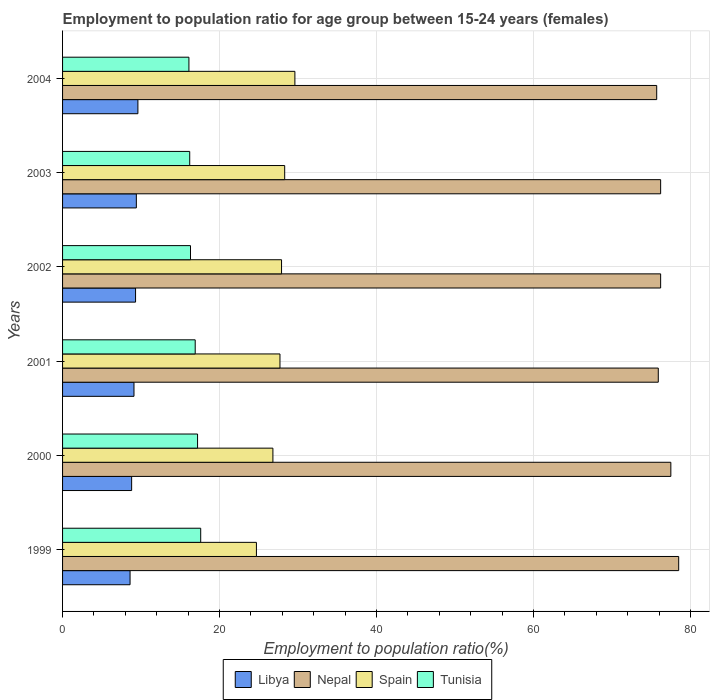How many bars are there on the 5th tick from the top?
Your answer should be compact. 4. How many bars are there on the 6th tick from the bottom?
Keep it short and to the point. 4. What is the label of the 3rd group of bars from the top?
Make the answer very short. 2002. What is the employment to population ratio in Libya in 1999?
Keep it short and to the point. 8.6. Across all years, what is the maximum employment to population ratio in Spain?
Offer a very short reply. 29.6. Across all years, what is the minimum employment to population ratio in Tunisia?
Ensure brevity in your answer.  16.1. In which year was the employment to population ratio in Nepal minimum?
Provide a succinct answer. 2004. What is the total employment to population ratio in Libya in the graph?
Offer a very short reply. 54.8. What is the difference between the employment to population ratio in Libya in 2004 and the employment to population ratio in Tunisia in 2001?
Make the answer very short. -7.3. What is the average employment to population ratio in Nepal per year?
Provide a succinct answer. 76.67. In the year 2004, what is the difference between the employment to population ratio in Spain and employment to population ratio in Nepal?
Give a very brief answer. -46.1. In how many years, is the employment to population ratio in Nepal greater than 32 %?
Give a very brief answer. 6. What is the ratio of the employment to population ratio in Spain in 2001 to that in 2003?
Your response must be concise. 0.98. Is the difference between the employment to population ratio in Spain in 2000 and 2004 greater than the difference between the employment to population ratio in Nepal in 2000 and 2004?
Make the answer very short. No. What is the difference between the highest and the second highest employment to population ratio in Libya?
Your answer should be compact. 0.2. What is the difference between the highest and the lowest employment to population ratio in Nepal?
Your answer should be very brief. 2.8. Is the sum of the employment to population ratio in Libya in 2002 and 2003 greater than the maximum employment to population ratio in Spain across all years?
Your response must be concise. No. What does the 2nd bar from the top in 2000 represents?
Provide a succinct answer. Spain. What does the 3rd bar from the bottom in 2004 represents?
Offer a terse response. Spain. Is it the case that in every year, the sum of the employment to population ratio in Tunisia and employment to population ratio in Libya is greater than the employment to population ratio in Spain?
Offer a very short reply. No. How many bars are there?
Your answer should be very brief. 24. How many years are there in the graph?
Provide a short and direct response. 6. Does the graph contain any zero values?
Make the answer very short. No. Does the graph contain grids?
Ensure brevity in your answer.  Yes. Where does the legend appear in the graph?
Offer a terse response. Bottom center. How are the legend labels stacked?
Offer a very short reply. Horizontal. What is the title of the graph?
Provide a short and direct response. Employment to population ratio for age group between 15-24 years (females). What is the label or title of the Y-axis?
Your answer should be compact. Years. What is the Employment to population ratio(%) in Libya in 1999?
Ensure brevity in your answer.  8.6. What is the Employment to population ratio(%) in Nepal in 1999?
Provide a short and direct response. 78.5. What is the Employment to population ratio(%) in Spain in 1999?
Make the answer very short. 24.7. What is the Employment to population ratio(%) of Tunisia in 1999?
Your response must be concise. 17.6. What is the Employment to population ratio(%) of Libya in 2000?
Your answer should be compact. 8.8. What is the Employment to population ratio(%) of Nepal in 2000?
Provide a succinct answer. 77.5. What is the Employment to population ratio(%) in Spain in 2000?
Provide a short and direct response. 26.8. What is the Employment to population ratio(%) in Tunisia in 2000?
Offer a very short reply. 17.2. What is the Employment to population ratio(%) of Libya in 2001?
Your answer should be very brief. 9.1. What is the Employment to population ratio(%) in Nepal in 2001?
Keep it short and to the point. 75.9. What is the Employment to population ratio(%) in Spain in 2001?
Keep it short and to the point. 27.7. What is the Employment to population ratio(%) in Tunisia in 2001?
Provide a short and direct response. 16.9. What is the Employment to population ratio(%) in Libya in 2002?
Provide a short and direct response. 9.3. What is the Employment to population ratio(%) in Nepal in 2002?
Your response must be concise. 76.2. What is the Employment to population ratio(%) of Spain in 2002?
Offer a very short reply. 27.9. What is the Employment to population ratio(%) of Tunisia in 2002?
Provide a succinct answer. 16.3. What is the Employment to population ratio(%) in Libya in 2003?
Make the answer very short. 9.4. What is the Employment to population ratio(%) of Nepal in 2003?
Your response must be concise. 76.2. What is the Employment to population ratio(%) in Spain in 2003?
Your answer should be very brief. 28.3. What is the Employment to population ratio(%) of Tunisia in 2003?
Ensure brevity in your answer.  16.2. What is the Employment to population ratio(%) of Libya in 2004?
Provide a short and direct response. 9.6. What is the Employment to population ratio(%) of Nepal in 2004?
Provide a short and direct response. 75.7. What is the Employment to population ratio(%) in Spain in 2004?
Keep it short and to the point. 29.6. What is the Employment to population ratio(%) in Tunisia in 2004?
Make the answer very short. 16.1. Across all years, what is the maximum Employment to population ratio(%) of Libya?
Your answer should be very brief. 9.6. Across all years, what is the maximum Employment to population ratio(%) of Nepal?
Your answer should be very brief. 78.5. Across all years, what is the maximum Employment to population ratio(%) of Spain?
Your response must be concise. 29.6. Across all years, what is the maximum Employment to population ratio(%) in Tunisia?
Provide a succinct answer. 17.6. Across all years, what is the minimum Employment to population ratio(%) in Libya?
Your response must be concise. 8.6. Across all years, what is the minimum Employment to population ratio(%) of Nepal?
Your answer should be very brief. 75.7. Across all years, what is the minimum Employment to population ratio(%) in Spain?
Your response must be concise. 24.7. Across all years, what is the minimum Employment to population ratio(%) in Tunisia?
Your response must be concise. 16.1. What is the total Employment to population ratio(%) in Libya in the graph?
Your response must be concise. 54.8. What is the total Employment to population ratio(%) of Nepal in the graph?
Make the answer very short. 460. What is the total Employment to population ratio(%) in Spain in the graph?
Give a very brief answer. 165. What is the total Employment to population ratio(%) in Tunisia in the graph?
Give a very brief answer. 100.3. What is the difference between the Employment to population ratio(%) of Libya in 1999 and that in 2000?
Make the answer very short. -0.2. What is the difference between the Employment to population ratio(%) of Tunisia in 1999 and that in 2000?
Provide a short and direct response. 0.4. What is the difference between the Employment to population ratio(%) of Spain in 1999 and that in 2001?
Your answer should be compact. -3. What is the difference between the Employment to population ratio(%) of Tunisia in 1999 and that in 2002?
Your answer should be very brief. 1.3. What is the difference between the Employment to population ratio(%) of Spain in 1999 and that in 2003?
Your answer should be compact. -3.6. What is the difference between the Employment to population ratio(%) of Tunisia in 1999 and that in 2003?
Offer a very short reply. 1.4. What is the difference between the Employment to population ratio(%) in Libya in 1999 and that in 2004?
Your answer should be very brief. -1. What is the difference between the Employment to population ratio(%) of Libya in 2000 and that in 2001?
Keep it short and to the point. -0.3. What is the difference between the Employment to population ratio(%) of Nepal in 2000 and that in 2001?
Keep it short and to the point. 1.6. What is the difference between the Employment to population ratio(%) in Libya in 2000 and that in 2003?
Your answer should be compact. -0.6. What is the difference between the Employment to population ratio(%) of Nepal in 2000 and that in 2003?
Give a very brief answer. 1.3. What is the difference between the Employment to population ratio(%) of Nepal in 2000 and that in 2004?
Provide a succinct answer. 1.8. What is the difference between the Employment to population ratio(%) of Spain in 2000 and that in 2004?
Offer a very short reply. -2.8. What is the difference between the Employment to population ratio(%) in Tunisia in 2000 and that in 2004?
Ensure brevity in your answer.  1.1. What is the difference between the Employment to population ratio(%) in Nepal in 2001 and that in 2002?
Your response must be concise. -0.3. What is the difference between the Employment to population ratio(%) in Spain in 2001 and that in 2002?
Offer a terse response. -0.2. What is the difference between the Employment to population ratio(%) in Tunisia in 2001 and that in 2002?
Your response must be concise. 0.6. What is the difference between the Employment to population ratio(%) in Nepal in 2001 and that in 2003?
Offer a terse response. -0.3. What is the difference between the Employment to population ratio(%) of Spain in 2001 and that in 2003?
Offer a terse response. -0.6. What is the difference between the Employment to population ratio(%) in Spain in 2001 and that in 2004?
Give a very brief answer. -1.9. What is the difference between the Employment to population ratio(%) in Tunisia in 2002 and that in 2003?
Provide a short and direct response. 0.1. What is the difference between the Employment to population ratio(%) in Libya in 2002 and that in 2004?
Provide a short and direct response. -0.3. What is the difference between the Employment to population ratio(%) in Libya in 2003 and that in 2004?
Provide a succinct answer. -0.2. What is the difference between the Employment to population ratio(%) in Nepal in 2003 and that in 2004?
Make the answer very short. 0.5. What is the difference between the Employment to population ratio(%) in Spain in 2003 and that in 2004?
Make the answer very short. -1.3. What is the difference between the Employment to population ratio(%) in Tunisia in 2003 and that in 2004?
Your answer should be very brief. 0.1. What is the difference between the Employment to population ratio(%) in Libya in 1999 and the Employment to population ratio(%) in Nepal in 2000?
Your answer should be compact. -68.9. What is the difference between the Employment to population ratio(%) of Libya in 1999 and the Employment to population ratio(%) of Spain in 2000?
Keep it short and to the point. -18.2. What is the difference between the Employment to population ratio(%) in Libya in 1999 and the Employment to population ratio(%) in Tunisia in 2000?
Provide a short and direct response. -8.6. What is the difference between the Employment to population ratio(%) of Nepal in 1999 and the Employment to population ratio(%) of Spain in 2000?
Provide a short and direct response. 51.7. What is the difference between the Employment to population ratio(%) of Nepal in 1999 and the Employment to population ratio(%) of Tunisia in 2000?
Give a very brief answer. 61.3. What is the difference between the Employment to population ratio(%) in Libya in 1999 and the Employment to population ratio(%) in Nepal in 2001?
Your answer should be very brief. -67.3. What is the difference between the Employment to population ratio(%) in Libya in 1999 and the Employment to population ratio(%) in Spain in 2001?
Your answer should be compact. -19.1. What is the difference between the Employment to population ratio(%) in Nepal in 1999 and the Employment to population ratio(%) in Spain in 2001?
Give a very brief answer. 50.8. What is the difference between the Employment to population ratio(%) in Nepal in 1999 and the Employment to population ratio(%) in Tunisia in 2001?
Offer a very short reply. 61.6. What is the difference between the Employment to population ratio(%) in Libya in 1999 and the Employment to population ratio(%) in Nepal in 2002?
Provide a short and direct response. -67.6. What is the difference between the Employment to population ratio(%) in Libya in 1999 and the Employment to population ratio(%) in Spain in 2002?
Offer a terse response. -19.3. What is the difference between the Employment to population ratio(%) of Nepal in 1999 and the Employment to population ratio(%) of Spain in 2002?
Make the answer very short. 50.6. What is the difference between the Employment to population ratio(%) in Nepal in 1999 and the Employment to population ratio(%) in Tunisia in 2002?
Provide a succinct answer. 62.2. What is the difference between the Employment to population ratio(%) in Libya in 1999 and the Employment to population ratio(%) in Nepal in 2003?
Provide a short and direct response. -67.6. What is the difference between the Employment to population ratio(%) in Libya in 1999 and the Employment to population ratio(%) in Spain in 2003?
Your answer should be compact. -19.7. What is the difference between the Employment to population ratio(%) in Nepal in 1999 and the Employment to population ratio(%) in Spain in 2003?
Provide a short and direct response. 50.2. What is the difference between the Employment to population ratio(%) in Nepal in 1999 and the Employment to population ratio(%) in Tunisia in 2003?
Make the answer very short. 62.3. What is the difference between the Employment to population ratio(%) of Spain in 1999 and the Employment to population ratio(%) of Tunisia in 2003?
Make the answer very short. 8.5. What is the difference between the Employment to population ratio(%) in Libya in 1999 and the Employment to population ratio(%) in Nepal in 2004?
Ensure brevity in your answer.  -67.1. What is the difference between the Employment to population ratio(%) of Libya in 1999 and the Employment to population ratio(%) of Tunisia in 2004?
Your answer should be compact. -7.5. What is the difference between the Employment to population ratio(%) of Nepal in 1999 and the Employment to population ratio(%) of Spain in 2004?
Give a very brief answer. 48.9. What is the difference between the Employment to population ratio(%) of Nepal in 1999 and the Employment to population ratio(%) of Tunisia in 2004?
Keep it short and to the point. 62.4. What is the difference between the Employment to population ratio(%) in Libya in 2000 and the Employment to population ratio(%) in Nepal in 2001?
Offer a very short reply. -67.1. What is the difference between the Employment to population ratio(%) in Libya in 2000 and the Employment to population ratio(%) in Spain in 2001?
Ensure brevity in your answer.  -18.9. What is the difference between the Employment to population ratio(%) of Libya in 2000 and the Employment to population ratio(%) of Tunisia in 2001?
Offer a terse response. -8.1. What is the difference between the Employment to population ratio(%) of Nepal in 2000 and the Employment to population ratio(%) of Spain in 2001?
Provide a short and direct response. 49.8. What is the difference between the Employment to population ratio(%) in Nepal in 2000 and the Employment to population ratio(%) in Tunisia in 2001?
Provide a succinct answer. 60.6. What is the difference between the Employment to population ratio(%) of Spain in 2000 and the Employment to population ratio(%) of Tunisia in 2001?
Your answer should be very brief. 9.9. What is the difference between the Employment to population ratio(%) of Libya in 2000 and the Employment to population ratio(%) of Nepal in 2002?
Give a very brief answer. -67.4. What is the difference between the Employment to population ratio(%) of Libya in 2000 and the Employment to population ratio(%) of Spain in 2002?
Give a very brief answer. -19.1. What is the difference between the Employment to population ratio(%) in Nepal in 2000 and the Employment to population ratio(%) in Spain in 2002?
Make the answer very short. 49.6. What is the difference between the Employment to population ratio(%) in Nepal in 2000 and the Employment to population ratio(%) in Tunisia in 2002?
Provide a succinct answer. 61.2. What is the difference between the Employment to population ratio(%) of Spain in 2000 and the Employment to population ratio(%) of Tunisia in 2002?
Ensure brevity in your answer.  10.5. What is the difference between the Employment to population ratio(%) in Libya in 2000 and the Employment to population ratio(%) in Nepal in 2003?
Your answer should be very brief. -67.4. What is the difference between the Employment to population ratio(%) in Libya in 2000 and the Employment to population ratio(%) in Spain in 2003?
Offer a terse response. -19.5. What is the difference between the Employment to population ratio(%) of Libya in 2000 and the Employment to population ratio(%) of Tunisia in 2003?
Give a very brief answer. -7.4. What is the difference between the Employment to population ratio(%) in Nepal in 2000 and the Employment to population ratio(%) in Spain in 2003?
Offer a terse response. 49.2. What is the difference between the Employment to population ratio(%) in Nepal in 2000 and the Employment to population ratio(%) in Tunisia in 2003?
Make the answer very short. 61.3. What is the difference between the Employment to population ratio(%) of Spain in 2000 and the Employment to population ratio(%) of Tunisia in 2003?
Make the answer very short. 10.6. What is the difference between the Employment to population ratio(%) of Libya in 2000 and the Employment to population ratio(%) of Nepal in 2004?
Give a very brief answer. -66.9. What is the difference between the Employment to population ratio(%) of Libya in 2000 and the Employment to population ratio(%) of Spain in 2004?
Keep it short and to the point. -20.8. What is the difference between the Employment to population ratio(%) of Nepal in 2000 and the Employment to population ratio(%) of Spain in 2004?
Keep it short and to the point. 47.9. What is the difference between the Employment to population ratio(%) in Nepal in 2000 and the Employment to population ratio(%) in Tunisia in 2004?
Your answer should be compact. 61.4. What is the difference between the Employment to population ratio(%) of Libya in 2001 and the Employment to population ratio(%) of Nepal in 2002?
Your answer should be compact. -67.1. What is the difference between the Employment to population ratio(%) in Libya in 2001 and the Employment to population ratio(%) in Spain in 2002?
Your answer should be very brief. -18.8. What is the difference between the Employment to population ratio(%) in Libya in 2001 and the Employment to population ratio(%) in Tunisia in 2002?
Offer a very short reply. -7.2. What is the difference between the Employment to population ratio(%) of Nepal in 2001 and the Employment to population ratio(%) of Spain in 2002?
Keep it short and to the point. 48. What is the difference between the Employment to population ratio(%) in Nepal in 2001 and the Employment to population ratio(%) in Tunisia in 2002?
Offer a very short reply. 59.6. What is the difference between the Employment to population ratio(%) in Libya in 2001 and the Employment to population ratio(%) in Nepal in 2003?
Keep it short and to the point. -67.1. What is the difference between the Employment to population ratio(%) in Libya in 2001 and the Employment to population ratio(%) in Spain in 2003?
Provide a succinct answer. -19.2. What is the difference between the Employment to population ratio(%) of Libya in 2001 and the Employment to population ratio(%) of Tunisia in 2003?
Your answer should be compact. -7.1. What is the difference between the Employment to population ratio(%) in Nepal in 2001 and the Employment to population ratio(%) in Spain in 2003?
Your response must be concise. 47.6. What is the difference between the Employment to population ratio(%) in Nepal in 2001 and the Employment to population ratio(%) in Tunisia in 2003?
Offer a very short reply. 59.7. What is the difference between the Employment to population ratio(%) in Libya in 2001 and the Employment to population ratio(%) in Nepal in 2004?
Ensure brevity in your answer.  -66.6. What is the difference between the Employment to population ratio(%) of Libya in 2001 and the Employment to population ratio(%) of Spain in 2004?
Keep it short and to the point. -20.5. What is the difference between the Employment to population ratio(%) of Libya in 2001 and the Employment to population ratio(%) of Tunisia in 2004?
Give a very brief answer. -7. What is the difference between the Employment to population ratio(%) in Nepal in 2001 and the Employment to population ratio(%) in Spain in 2004?
Ensure brevity in your answer.  46.3. What is the difference between the Employment to population ratio(%) of Nepal in 2001 and the Employment to population ratio(%) of Tunisia in 2004?
Give a very brief answer. 59.8. What is the difference between the Employment to population ratio(%) in Spain in 2001 and the Employment to population ratio(%) in Tunisia in 2004?
Provide a short and direct response. 11.6. What is the difference between the Employment to population ratio(%) in Libya in 2002 and the Employment to population ratio(%) in Nepal in 2003?
Provide a succinct answer. -66.9. What is the difference between the Employment to population ratio(%) of Nepal in 2002 and the Employment to population ratio(%) of Spain in 2003?
Offer a terse response. 47.9. What is the difference between the Employment to population ratio(%) in Nepal in 2002 and the Employment to population ratio(%) in Tunisia in 2003?
Ensure brevity in your answer.  60. What is the difference between the Employment to population ratio(%) in Spain in 2002 and the Employment to population ratio(%) in Tunisia in 2003?
Make the answer very short. 11.7. What is the difference between the Employment to population ratio(%) of Libya in 2002 and the Employment to population ratio(%) of Nepal in 2004?
Offer a terse response. -66.4. What is the difference between the Employment to population ratio(%) in Libya in 2002 and the Employment to population ratio(%) in Spain in 2004?
Provide a succinct answer. -20.3. What is the difference between the Employment to population ratio(%) of Libya in 2002 and the Employment to population ratio(%) of Tunisia in 2004?
Ensure brevity in your answer.  -6.8. What is the difference between the Employment to population ratio(%) of Nepal in 2002 and the Employment to population ratio(%) of Spain in 2004?
Provide a succinct answer. 46.6. What is the difference between the Employment to population ratio(%) of Nepal in 2002 and the Employment to population ratio(%) of Tunisia in 2004?
Your answer should be very brief. 60.1. What is the difference between the Employment to population ratio(%) in Libya in 2003 and the Employment to population ratio(%) in Nepal in 2004?
Give a very brief answer. -66.3. What is the difference between the Employment to population ratio(%) of Libya in 2003 and the Employment to population ratio(%) of Spain in 2004?
Your answer should be compact. -20.2. What is the difference between the Employment to population ratio(%) in Libya in 2003 and the Employment to population ratio(%) in Tunisia in 2004?
Provide a succinct answer. -6.7. What is the difference between the Employment to population ratio(%) of Nepal in 2003 and the Employment to population ratio(%) of Spain in 2004?
Your answer should be very brief. 46.6. What is the difference between the Employment to population ratio(%) in Nepal in 2003 and the Employment to population ratio(%) in Tunisia in 2004?
Your response must be concise. 60.1. What is the difference between the Employment to population ratio(%) in Spain in 2003 and the Employment to population ratio(%) in Tunisia in 2004?
Your response must be concise. 12.2. What is the average Employment to population ratio(%) of Libya per year?
Your response must be concise. 9.13. What is the average Employment to population ratio(%) of Nepal per year?
Give a very brief answer. 76.67. What is the average Employment to population ratio(%) of Spain per year?
Ensure brevity in your answer.  27.5. What is the average Employment to population ratio(%) in Tunisia per year?
Give a very brief answer. 16.72. In the year 1999, what is the difference between the Employment to population ratio(%) of Libya and Employment to population ratio(%) of Nepal?
Provide a succinct answer. -69.9. In the year 1999, what is the difference between the Employment to population ratio(%) in Libya and Employment to population ratio(%) in Spain?
Give a very brief answer. -16.1. In the year 1999, what is the difference between the Employment to population ratio(%) in Nepal and Employment to population ratio(%) in Spain?
Provide a succinct answer. 53.8. In the year 1999, what is the difference between the Employment to population ratio(%) of Nepal and Employment to population ratio(%) of Tunisia?
Keep it short and to the point. 60.9. In the year 1999, what is the difference between the Employment to population ratio(%) in Spain and Employment to population ratio(%) in Tunisia?
Give a very brief answer. 7.1. In the year 2000, what is the difference between the Employment to population ratio(%) in Libya and Employment to population ratio(%) in Nepal?
Ensure brevity in your answer.  -68.7. In the year 2000, what is the difference between the Employment to population ratio(%) in Nepal and Employment to population ratio(%) in Spain?
Provide a short and direct response. 50.7. In the year 2000, what is the difference between the Employment to population ratio(%) of Nepal and Employment to population ratio(%) of Tunisia?
Offer a very short reply. 60.3. In the year 2001, what is the difference between the Employment to population ratio(%) in Libya and Employment to population ratio(%) in Nepal?
Offer a very short reply. -66.8. In the year 2001, what is the difference between the Employment to population ratio(%) of Libya and Employment to population ratio(%) of Spain?
Provide a succinct answer. -18.6. In the year 2001, what is the difference between the Employment to population ratio(%) in Nepal and Employment to population ratio(%) in Spain?
Offer a terse response. 48.2. In the year 2001, what is the difference between the Employment to population ratio(%) of Nepal and Employment to population ratio(%) of Tunisia?
Provide a succinct answer. 59. In the year 2002, what is the difference between the Employment to population ratio(%) of Libya and Employment to population ratio(%) of Nepal?
Provide a succinct answer. -66.9. In the year 2002, what is the difference between the Employment to population ratio(%) in Libya and Employment to population ratio(%) in Spain?
Give a very brief answer. -18.6. In the year 2002, what is the difference between the Employment to population ratio(%) in Libya and Employment to population ratio(%) in Tunisia?
Offer a very short reply. -7. In the year 2002, what is the difference between the Employment to population ratio(%) of Nepal and Employment to population ratio(%) of Spain?
Provide a short and direct response. 48.3. In the year 2002, what is the difference between the Employment to population ratio(%) in Nepal and Employment to population ratio(%) in Tunisia?
Provide a succinct answer. 59.9. In the year 2003, what is the difference between the Employment to population ratio(%) in Libya and Employment to population ratio(%) in Nepal?
Ensure brevity in your answer.  -66.8. In the year 2003, what is the difference between the Employment to population ratio(%) of Libya and Employment to population ratio(%) of Spain?
Your answer should be very brief. -18.9. In the year 2003, what is the difference between the Employment to population ratio(%) of Libya and Employment to population ratio(%) of Tunisia?
Keep it short and to the point. -6.8. In the year 2003, what is the difference between the Employment to population ratio(%) in Nepal and Employment to population ratio(%) in Spain?
Offer a very short reply. 47.9. In the year 2003, what is the difference between the Employment to population ratio(%) of Nepal and Employment to population ratio(%) of Tunisia?
Your answer should be compact. 60. In the year 2004, what is the difference between the Employment to population ratio(%) in Libya and Employment to population ratio(%) in Nepal?
Offer a very short reply. -66.1. In the year 2004, what is the difference between the Employment to population ratio(%) in Nepal and Employment to population ratio(%) in Spain?
Ensure brevity in your answer.  46.1. In the year 2004, what is the difference between the Employment to population ratio(%) in Nepal and Employment to population ratio(%) in Tunisia?
Ensure brevity in your answer.  59.6. In the year 2004, what is the difference between the Employment to population ratio(%) in Spain and Employment to population ratio(%) in Tunisia?
Your answer should be compact. 13.5. What is the ratio of the Employment to population ratio(%) in Libya in 1999 to that in 2000?
Provide a succinct answer. 0.98. What is the ratio of the Employment to population ratio(%) in Nepal in 1999 to that in 2000?
Make the answer very short. 1.01. What is the ratio of the Employment to population ratio(%) of Spain in 1999 to that in 2000?
Keep it short and to the point. 0.92. What is the ratio of the Employment to population ratio(%) in Tunisia in 1999 to that in 2000?
Provide a succinct answer. 1.02. What is the ratio of the Employment to population ratio(%) of Libya in 1999 to that in 2001?
Keep it short and to the point. 0.95. What is the ratio of the Employment to population ratio(%) of Nepal in 1999 to that in 2001?
Your response must be concise. 1.03. What is the ratio of the Employment to population ratio(%) of Spain in 1999 to that in 2001?
Offer a terse response. 0.89. What is the ratio of the Employment to population ratio(%) in Tunisia in 1999 to that in 2001?
Provide a succinct answer. 1.04. What is the ratio of the Employment to population ratio(%) of Libya in 1999 to that in 2002?
Make the answer very short. 0.92. What is the ratio of the Employment to population ratio(%) in Nepal in 1999 to that in 2002?
Provide a succinct answer. 1.03. What is the ratio of the Employment to population ratio(%) of Spain in 1999 to that in 2002?
Offer a very short reply. 0.89. What is the ratio of the Employment to population ratio(%) of Tunisia in 1999 to that in 2002?
Provide a short and direct response. 1.08. What is the ratio of the Employment to population ratio(%) of Libya in 1999 to that in 2003?
Ensure brevity in your answer.  0.91. What is the ratio of the Employment to population ratio(%) of Nepal in 1999 to that in 2003?
Offer a very short reply. 1.03. What is the ratio of the Employment to population ratio(%) in Spain in 1999 to that in 2003?
Your answer should be very brief. 0.87. What is the ratio of the Employment to population ratio(%) in Tunisia in 1999 to that in 2003?
Your answer should be very brief. 1.09. What is the ratio of the Employment to population ratio(%) of Libya in 1999 to that in 2004?
Offer a terse response. 0.9. What is the ratio of the Employment to population ratio(%) of Spain in 1999 to that in 2004?
Provide a succinct answer. 0.83. What is the ratio of the Employment to population ratio(%) in Tunisia in 1999 to that in 2004?
Offer a very short reply. 1.09. What is the ratio of the Employment to population ratio(%) in Libya in 2000 to that in 2001?
Make the answer very short. 0.97. What is the ratio of the Employment to population ratio(%) in Nepal in 2000 to that in 2001?
Keep it short and to the point. 1.02. What is the ratio of the Employment to population ratio(%) of Spain in 2000 to that in 2001?
Provide a short and direct response. 0.97. What is the ratio of the Employment to population ratio(%) in Tunisia in 2000 to that in 2001?
Make the answer very short. 1.02. What is the ratio of the Employment to population ratio(%) of Libya in 2000 to that in 2002?
Provide a succinct answer. 0.95. What is the ratio of the Employment to population ratio(%) in Nepal in 2000 to that in 2002?
Give a very brief answer. 1.02. What is the ratio of the Employment to population ratio(%) in Spain in 2000 to that in 2002?
Your answer should be very brief. 0.96. What is the ratio of the Employment to population ratio(%) in Tunisia in 2000 to that in 2002?
Ensure brevity in your answer.  1.06. What is the ratio of the Employment to population ratio(%) in Libya in 2000 to that in 2003?
Provide a short and direct response. 0.94. What is the ratio of the Employment to population ratio(%) in Nepal in 2000 to that in 2003?
Your response must be concise. 1.02. What is the ratio of the Employment to population ratio(%) in Spain in 2000 to that in 2003?
Provide a succinct answer. 0.95. What is the ratio of the Employment to population ratio(%) in Tunisia in 2000 to that in 2003?
Your response must be concise. 1.06. What is the ratio of the Employment to population ratio(%) in Libya in 2000 to that in 2004?
Your response must be concise. 0.92. What is the ratio of the Employment to population ratio(%) in Nepal in 2000 to that in 2004?
Your answer should be very brief. 1.02. What is the ratio of the Employment to population ratio(%) in Spain in 2000 to that in 2004?
Offer a very short reply. 0.91. What is the ratio of the Employment to population ratio(%) in Tunisia in 2000 to that in 2004?
Give a very brief answer. 1.07. What is the ratio of the Employment to population ratio(%) in Libya in 2001 to that in 2002?
Provide a succinct answer. 0.98. What is the ratio of the Employment to population ratio(%) in Nepal in 2001 to that in 2002?
Your answer should be compact. 1. What is the ratio of the Employment to population ratio(%) of Tunisia in 2001 to that in 2002?
Keep it short and to the point. 1.04. What is the ratio of the Employment to population ratio(%) in Libya in 2001 to that in 2003?
Give a very brief answer. 0.97. What is the ratio of the Employment to population ratio(%) in Nepal in 2001 to that in 2003?
Keep it short and to the point. 1. What is the ratio of the Employment to population ratio(%) in Spain in 2001 to that in 2003?
Your response must be concise. 0.98. What is the ratio of the Employment to population ratio(%) of Tunisia in 2001 to that in 2003?
Keep it short and to the point. 1.04. What is the ratio of the Employment to population ratio(%) in Libya in 2001 to that in 2004?
Provide a succinct answer. 0.95. What is the ratio of the Employment to population ratio(%) in Spain in 2001 to that in 2004?
Give a very brief answer. 0.94. What is the ratio of the Employment to population ratio(%) of Tunisia in 2001 to that in 2004?
Provide a short and direct response. 1.05. What is the ratio of the Employment to population ratio(%) of Libya in 2002 to that in 2003?
Provide a succinct answer. 0.99. What is the ratio of the Employment to population ratio(%) in Nepal in 2002 to that in 2003?
Offer a terse response. 1. What is the ratio of the Employment to population ratio(%) in Spain in 2002 to that in 2003?
Offer a very short reply. 0.99. What is the ratio of the Employment to population ratio(%) in Libya in 2002 to that in 2004?
Ensure brevity in your answer.  0.97. What is the ratio of the Employment to population ratio(%) of Nepal in 2002 to that in 2004?
Make the answer very short. 1.01. What is the ratio of the Employment to population ratio(%) of Spain in 2002 to that in 2004?
Provide a short and direct response. 0.94. What is the ratio of the Employment to population ratio(%) in Tunisia in 2002 to that in 2004?
Offer a terse response. 1.01. What is the ratio of the Employment to population ratio(%) in Libya in 2003 to that in 2004?
Give a very brief answer. 0.98. What is the ratio of the Employment to population ratio(%) in Nepal in 2003 to that in 2004?
Make the answer very short. 1.01. What is the ratio of the Employment to population ratio(%) in Spain in 2003 to that in 2004?
Your response must be concise. 0.96. What is the ratio of the Employment to population ratio(%) in Tunisia in 2003 to that in 2004?
Offer a terse response. 1.01. What is the difference between the highest and the second highest Employment to population ratio(%) in Nepal?
Provide a succinct answer. 1. What is the difference between the highest and the second highest Employment to population ratio(%) of Spain?
Give a very brief answer. 1.3. 